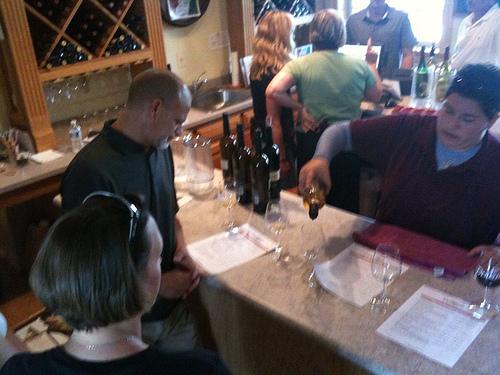Is there alcohol in the photo?
Concise answer only. Yes. What does the woman in the forefront have on her head?
Short answer required. Sunglasses. How many people are in the photo?
Give a very brief answer. 7. 